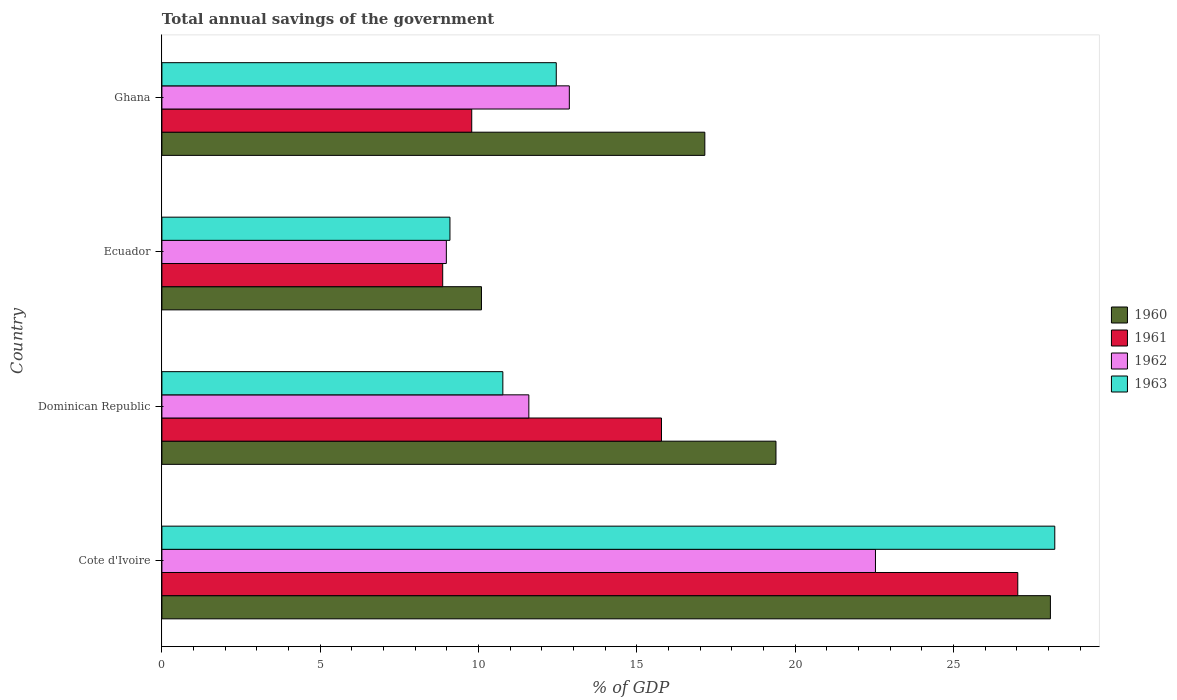How many different coloured bars are there?
Make the answer very short. 4. How many groups of bars are there?
Give a very brief answer. 4. Are the number of bars on each tick of the Y-axis equal?
Offer a very short reply. Yes. How many bars are there on the 2nd tick from the top?
Offer a terse response. 4. How many bars are there on the 4th tick from the bottom?
Offer a very short reply. 4. What is the label of the 2nd group of bars from the top?
Offer a very short reply. Ecuador. In how many cases, is the number of bars for a given country not equal to the number of legend labels?
Offer a very short reply. 0. What is the total annual savings of the government in 1960 in Dominican Republic?
Provide a short and direct response. 19.39. Across all countries, what is the maximum total annual savings of the government in 1962?
Your answer should be very brief. 22.54. Across all countries, what is the minimum total annual savings of the government in 1962?
Your answer should be compact. 8.98. In which country was the total annual savings of the government in 1963 maximum?
Provide a short and direct response. Cote d'Ivoire. In which country was the total annual savings of the government in 1963 minimum?
Give a very brief answer. Ecuador. What is the total total annual savings of the government in 1960 in the graph?
Provide a succinct answer. 74.69. What is the difference between the total annual savings of the government in 1960 in Dominican Republic and that in Ecuador?
Give a very brief answer. 9.3. What is the difference between the total annual savings of the government in 1963 in Dominican Republic and the total annual savings of the government in 1960 in Ecuador?
Your answer should be compact. 0.67. What is the average total annual savings of the government in 1963 per country?
Offer a very short reply. 15.13. What is the difference between the total annual savings of the government in 1960 and total annual savings of the government in 1961 in Dominican Republic?
Your answer should be very brief. 3.62. In how many countries, is the total annual savings of the government in 1960 greater than 19 %?
Provide a short and direct response. 2. What is the ratio of the total annual savings of the government in 1960 in Cote d'Ivoire to that in Ecuador?
Your answer should be very brief. 2.78. What is the difference between the highest and the second highest total annual savings of the government in 1963?
Give a very brief answer. 15.74. What is the difference between the highest and the lowest total annual savings of the government in 1962?
Provide a succinct answer. 13.55. What does the 4th bar from the top in Cote d'Ivoire represents?
Your response must be concise. 1960. How many bars are there?
Ensure brevity in your answer.  16. Are all the bars in the graph horizontal?
Ensure brevity in your answer.  Yes. Does the graph contain any zero values?
Your response must be concise. No. Where does the legend appear in the graph?
Offer a very short reply. Center right. How are the legend labels stacked?
Keep it short and to the point. Vertical. What is the title of the graph?
Provide a succinct answer. Total annual savings of the government. What is the label or title of the X-axis?
Offer a terse response. % of GDP. What is the % of GDP in 1960 in Cote d'Ivoire?
Provide a short and direct response. 28.06. What is the % of GDP in 1961 in Cote d'Ivoire?
Provide a short and direct response. 27.03. What is the % of GDP of 1962 in Cote d'Ivoire?
Make the answer very short. 22.54. What is the % of GDP in 1963 in Cote d'Ivoire?
Your answer should be compact. 28.2. What is the % of GDP of 1960 in Dominican Republic?
Your answer should be compact. 19.39. What is the % of GDP of 1961 in Dominican Republic?
Offer a terse response. 15.78. What is the % of GDP in 1962 in Dominican Republic?
Offer a terse response. 11.59. What is the % of GDP in 1963 in Dominican Republic?
Ensure brevity in your answer.  10.77. What is the % of GDP in 1960 in Ecuador?
Provide a short and direct response. 10.09. What is the % of GDP in 1961 in Ecuador?
Offer a terse response. 8.87. What is the % of GDP in 1962 in Ecuador?
Give a very brief answer. 8.98. What is the % of GDP in 1963 in Ecuador?
Make the answer very short. 9.1. What is the % of GDP in 1960 in Ghana?
Keep it short and to the point. 17.15. What is the % of GDP in 1961 in Ghana?
Your response must be concise. 9.78. What is the % of GDP of 1962 in Ghana?
Your answer should be compact. 12.87. What is the % of GDP in 1963 in Ghana?
Provide a succinct answer. 12.45. Across all countries, what is the maximum % of GDP of 1960?
Ensure brevity in your answer.  28.06. Across all countries, what is the maximum % of GDP in 1961?
Your answer should be compact. 27.03. Across all countries, what is the maximum % of GDP in 1962?
Your answer should be very brief. 22.54. Across all countries, what is the maximum % of GDP in 1963?
Ensure brevity in your answer.  28.2. Across all countries, what is the minimum % of GDP of 1960?
Make the answer very short. 10.09. Across all countries, what is the minimum % of GDP in 1961?
Your response must be concise. 8.87. Across all countries, what is the minimum % of GDP in 1962?
Provide a succinct answer. 8.98. Across all countries, what is the minimum % of GDP in 1963?
Provide a short and direct response. 9.1. What is the total % of GDP of 1960 in the graph?
Keep it short and to the point. 74.69. What is the total % of GDP of 1961 in the graph?
Provide a succinct answer. 61.46. What is the total % of GDP in 1962 in the graph?
Ensure brevity in your answer.  55.97. What is the total % of GDP of 1963 in the graph?
Make the answer very short. 60.52. What is the difference between the % of GDP of 1960 in Cote d'Ivoire and that in Dominican Republic?
Offer a very short reply. 8.67. What is the difference between the % of GDP of 1961 in Cote d'Ivoire and that in Dominican Republic?
Your answer should be very brief. 11.25. What is the difference between the % of GDP in 1962 in Cote d'Ivoire and that in Dominican Republic?
Your response must be concise. 10.95. What is the difference between the % of GDP in 1963 in Cote d'Ivoire and that in Dominican Republic?
Your answer should be very brief. 17.43. What is the difference between the % of GDP in 1960 in Cote d'Ivoire and that in Ecuador?
Your response must be concise. 17.97. What is the difference between the % of GDP of 1961 in Cote d'Ivoire and that in Ecuador?
Ensure brevity in your answer.  18.16. What is the difference between the % of GDP in 1962 in Cote d'Ivoire and that in Ecuador?
Offer a terse response. 13.55. What is the difference between the % of GDP in 1963 in Cote d'Ivoire and that in Ecuador?
Offer a terse response. 19.1. What is the difference between the % of GDP in 1960 in Cote d'Ivoire and that in Ghana?
Your response must be concise. 10.91. What is the difference between the % of GDP in 1961 in Cote d'Ivoire and that in Ghana?
Give a very brief answer. 17.25. What is the difference between the % of GDP in 1962 in Cote d'Ivoire and that in Ghana?
Your answer should be compact. 9.67. What is the difference between the % of GDP of 1963 in Cote d'Ivoire and that in Ghana?
Offer a terse response. 15.74. What is the difference between the % of GDP in 1960 in Dominican Republic and that in Ecuador?
Make the answer very short. 9.3. What is the difference between the % of GDP of 1961 in Dominican Republic and that in Ecuador?
Your answer should be compact. 6.91. What is the difference between the % of GDP of 1962 in Dominican Republic and that in Ecuador?
Your answer should be very brief. 2.61. What is the difference between the % of GDP of 1963 in Dominican Republic and that in Ecuador?
Keep it short and to the point. 1.67. What is the difference between the % of GDP of 1960 in Dominican Republic and that in Ghana?
Offer a terse response. 2.25. What is the difference between the % of GDP of 1961 in Dominican Republic and that in Ghana?
Make the answer very short. 5.99. What is the difference between the % of GDP of 1962 in Dominican Republic and that in Ghana?
Give a very brief answer. -1.28. What is the difference between the % of GDP in 1963 in Dominican Republic and that in Ghana?
Offer a terse response. -1.69. What is the difference between the % of GDP of 1960 in Ecuador and that in Ghana?
Your answer should be compact. -7.05. What is the difference between the % of GDP of 1961 in Ecuador and that in Ghana?
Your answer should be very brief. -0.92. What is the difference between the % of GDP of 1962 in Ecuador and that in Ghana?
Provide a succinct answer. -3.88. What is the difference between the % of GDP in 1963 in Ecuador and that in Ghana?
Ensure brevity in your answer.  -3.36. What is the difference between the % of GDP in 1960 in Cote d'Ivoire and the % of GDP in 1961 in Dominican Republic?
Provide a short and direct response. 12.28. What is the difference between the % of GDP of 1960 in Cote d'Ivoire and the % of GDP of 1962 in Dominican Republic?
Provide a short and direct response. 16.47. What is the difference between the % of GDP in 1960 in Cote d'Ivoire and the % of GDP in 1963 in Dominican Republic?
Your answer should be very brief. 17.29. What is the difference between the % of GDP of 1961 in Cote d'Ivoire and the % of GDP of 1962 in Dominican Republic?
Your answer should be very brief. 15.44. What is the difference between the % of GDP in 1961 in Cote d'Ivoire and the % of GDP in 1963 in Dominican Republic?
Your answer should be very brief. 16.26. What is the difference between the % of GDP in 1962 in Cote d'Ivoire and the % of GDP in 1963 in Dominican Republic?
Provide a short and direct response. 11.77. What is the difference between the % of GDP of 1960 in Cote d'Ivoire and the % of GDP of 1961 in Ecuador?
Your answer should be compact. 19.19. What is the difference between the % of GDP of 1960 in Cote d'Ivoire and the % of GDP of 1962 in Ecuador?
Offer a very short reply. 19.08. What is the difference between the % of GDP of 1960 in Cote d'Ivoire and the % of GDP of 1963 in Ecuador?
Your answer should be very brief. 18.96. What is the difference between the % of GDP of 1961 in Cote d'Ivoire and the % of GDP of 1962 in Ecuador?
Ensure brevity in your answer.  18.05. What is the difference between the % of GDP of 1961 in Cote d'Ivoire and the % of GDP of 1963 in Ecuador?
Make the answer very short. 17.93. What is the difference between the % of GDP in 1962 in Cote d'Ivoire and the % of GDP in 1963 in Ecuador?
Your response must be concise. 13.44. What is the difference between the % of GDP of 1960 in Cote d'Ivoire and the % of GDP of 1961 in Ghana?
Ensure brevity in your answer.  18.27. What is the difference between the % of GDP of 1960 in Cote d'Ivoire and the % of GDP of 1962 in Ghana?
Offer a terse response. 15.19. What is the difference between the % of GDP in 1960 in Cote d'Ivoire and the % of GDP in 1963 in Ghana?
Your response must be concise. 15.61. What is the difference between the % of GDP in 1961 in Cote d'Ivoire and the % of GDP in 1962 in Ghana?
Offer a very short reply. 14.16. What is the difference between the % of GDP in 1961 in Cote d'Ivoire and the % of GDP in 1963 in Ghana?
Ensure brevity in your answer.  14.58. What is the difference between the % of GDP in 1962 in Cote d'Ivoire and the % of GDP in 1963 in Ghana?
Provide a succinct answer. 10.08. What is the difference between the % of GDP of 1960 in Dominican Republic and the % of GDP of 1961 in Ecuador?
Your answer should be very brief. 10.53. What is the difference between the % of GDP of 1960 in Dominican Republic and the % of GDP of 1962 in Ecuador?
Provide a succinct answer. 10.41. What is the difference between the % of GDP in 1960 in Dominican Republic and the % of GDP in 1963 in Ecuador?
Your answer should be very brief. 10.3. What is the difference between the % of GDP of 1961 in Dominican Republic and the % of GDP of 1962 in Ecuador?
Provide a short and direct response. 6.79. What is the difference between the % of GDP of 1961 in Dominican Republic and the % of GDP of 1963 in Ecuador?
Give a very brief answer. 6.68. What is the difference between the % of GDP in 1962 in Dominican Republic and the % of GDP in 1963 in Ecuador?
Offer a very short reply. 2.49. What is the difference between the % of GDP in 1960 in Dominican Republic and the % of GDP in 1961 in Ghana?
Keep it short and to the point. 9.61. What is the difference between the % of GDP of 1960 in Dominican Republic and the % of GDP of 1962 in Ghana?
Your answer should be compact. 6.53. What is the difference between the % of GDP in 1960 in Dominican Republic and the % of GDP in 1963 in Ghana?
Give a very brief answer. 6.94. What is the difference between the % of GDP of 1961 in Dominican Republic and the % of GDP of 1962 in Ghana?
Offer a terse response. 2.91. What is the difference between the % of GDP of 1961 in Dominican Republic and the % of GDP of 1963 in Ghana?
Offer a terse response. 3.32. What is the difference between the % of GDP in 1962 in Dominican Republic and the % of GDP in 1963 in Ghana?
Your answer should be very brief. -0.87. What is the difference between the % of GDP in 1960 in Ecuador and the % of GDP in 1961 in Ghana?
Your answer should be very brief. 0.31. What is the difference between the % of GDP in 1960 in Ecuador and the % of GDP in 1962 in Ghana?
Your response must be concise. -2.77. What is the difference between the % of GDP of 1960 in Ecuador and the % of GDP of 1963 in Ghana?
Provide a succinct answer. -2.36. What is the difference between the % of GDP of 1961 in Ecuador and the % of GDP of 1962 in Ghana?
Provide a short and direct response. -4. What is the difference between the % of GDP of 1961 in Ecuador and the % of GDP of 1963 in Ghana?
Provide a short and direct response. -3.59. What is the difference between the % of GDP of 1962 in Ecuador and the % of GDP of 1963 in Ghana?
Provide a short and direct response. -3.47. What is the average % of GDP of 1960 per country?
Ensure brevity in your answer.  18.67. What is the average % of GDP of 1961 per country?
Ensure brevity in your answer.  15.37. What is the average % of GDP of 1962 per country?
Provide a succinct answer. 13.99. What is the average % of GDP of 1963 per country?
Provide a short and direct response. 15.13. What is the difference between the % of GDP of 1960 and % of GDP of 1961 in Cote d'Ivoire?
Your response must be concise. 1.03. What is the difference between the % of GDP of 1960 and % of GDP of 1962 in Cote d'Ivoire?
Your answer should be very brief. 5.52. What is the difference between the % of GDP of 1960 and % of GDP of 1963 in Cote d'Ivoire?
Your answer should be compact. -0.14. What is the difference between the % of GDP of 1961 and % of GDP of 1962 in Cote d'Ivoire?
Ensure brevity in your answer.  4.49. What is the difference between the % of GDP of 1961 and % of GDP of 1963 in Cote d'Ivoire?
Your response must be concise. -1.17. What is the difference between the % of GDP of 1962 and % of GDP of 1963 in Cote d'Ivoire?
Offer a terse response. -5.66. What is the difference between the % of GDP of 1960 and % of GDP of 1961 in Dominican Republic?
Your response must be concise. 3.62. What is the difference between the % of GDP in 1960 and % of GDP in 1962 in Dominican Republic?
Ensure brevity in your answer.  7.8. What is the difference between the % of GDP in 1960 and % of GDP in 1963 in Dominican Republic?
Provide a succinct answer. 8.63. What is the difference between the % of GDP of 1961 and % of GDP of 1962 in Dominican Republic?
Give a very brief answer. 4.19. What is the difference between the % of GDP of 1961 and % of GDP of 1963 in Dominican Republic?
Your response must be concise. 5.01. What is the difference between the % of GDP in 1962 and % of GDP in 1963 in Dominican Republic?
Provide a short and direct response. 0.82. What is the difference between the % of GDP of 1960 and % of GDP of 1961 in Ecuador?
Your answer should be compact. 1.22. What is the difference between the % of GDP of 1960 and % of GDP of 1962 in Ecuador?
Provide a succinct answer. 1.11. What is the difference between the % of GDP in 1961 and % of GDP in 1962 in Ecuador?
Give a very brief answer. -0.12. What is the difference between the % of GDP in 1961 and % of GDP in 1963 in Ecuador?
Ensure brevity in your answer.  -0.23. What is the difference between the % of GDP of 1962 and % of GDP of 1963 in Ecuador?
Provide a succinct answer. -0.11. What is the difference between the % of GDP in 1960 and % of GDP in 1961 in Ghana?
Your response must be concise. 7.36. What is the difference between the % of GDP in 1960 and % of GDP in 1962 in Ghana?
Your response must be concise. 4.28. What is the difference between the % of GDP in 1960 and % of GDP in 1963 in Ghana?
Make the answer very short. 4.69. What is the difference between the % of GDP in 1961 and % of GDP in 1962 in Ghana?
Provide a short and direct response. -3.08. What is the difference between the % of GDP in 1961 and % of GDP in 1963 in Ghana?
Keep it short and to the point. -2.67. What is the difference between the % of GDP of 1962 and % of GDP of 1963 in Ghana?
Give a very brief answer. 0.41. What is the ratio of the % of GDP of 1960 in Cote d'Ivoire to that in Dominican Republic?
Keep it short and to the point. 1.45. What is the ratio of the % of GDP of 1961 in Cote d'Ivoire to that in Dominican Republic?
Provide a short and direct response. 1.71. What is the ratio of the % of GDP in 1962 in Cote d'Ivoire to that in Dominican Republic?
Make the answer very short. 1.94. What is the ratio of the % of GDP of 1963 in Cote d'Ivoire to that in Dominican Republic?
Give a very brief answer. 2.62. What is the ratio of the % of GDP in 1960 in Cote d'Ivoire to that in Ecuador?
Provide a succinct answer. 2.78. What is the ratio of the % of GDP in 1961 in Cote d'Ivoire to that in Ecuador?
Your answer should be compact. 3.05. What is the ratio of the % of GDP in 1962 in Cote d'Ivoire to that in Ecuador?
Your answer should be compact. 2.51. What is the ratio of the % of GDP of 1963 in Cote d'Ivoire to that in Ecuador?
Offer a very short reply. 3.1. What is the ratio of the % of GDP of 1960 in Cote d'Ivoire to that in Ghana?
Provide a succinct answer. 1.64. What is the ratio of the % of GDP of 1961 in Cote d'Ivoire to that in Ghana?
Offer a very short reply. 2.76. What is the ratio of the % of GDP in 1962 in Cote d'Ivoire to that in Ghana?
Your response must be concise. 1.75. What is the ratio of the % of GDP of 1963 in Cote d'Ivoire to that in Ghana?
Give a very brief answer. 2.26. What is the ratio of the % of GDP in 1960 in Dominican Republic to that in Ecuador?
Provide a succinct answer. 1.92. What is the ratio of the % of GDP of 1961 in Dominican Republic to that in Ecuador?
Provide a short and direct response. 1.78. What is the ratio of the % of GDP of 1962 in Dominican Republic to that in Ecuador?
Your answer should be very brief. 1.29. What is the ratio of the % of GDP of 1963 in Dominican Republic to that in Ecuador?
Offer a terse response. 1.18. What is the ratio of the % of GDP in 1960 in Dominican Republic to that in Ghana?
Offer a very short reply. 1.13. What is the ratio of the % of GDP of 1961 in Dominican Republic to that in Ghana?
Give a very brief answer. 1.61. What is the ratio of the % of GDP in 1962 in Dominican Republic to that in Ghana?
Make the answer very short. 0.9. What is the ratio of the % of GDP in 1963 in Dominican Republic to that in Ghana?
Keep it short and to the point. 0.86. What is the ratio of the % of GDP of 1960 in Ecuador to that in Ghana?
Your answer should be compact. 0.59. What is the ratio of the % of GDP in 1961 in Ecuador to that in Ghana?
Your answer should be very brief. 0.91. What is the ratio of the % of GDP in 1962 in Ecuador to that in Ghana?
Your answer should be compact. 0.7. What is the ratio of the % of GDP of 1963 in Ecuador to that in Ghana?
Keep it short and to the point. 0.73. What is the difference between the highest and the second highest % of GDP of 1960?
Make the answer very short. 8.67. What is the difference between the highest and the second highest % of GDP in 1961?
Your response must be concise. 11.25. What is the difference between the highest and the second highest % of GDP of 1962?
Give a very brief answer. 9.67. What is the difference between the highest and the second highest % of GDP of 1963?
Keep it short and to the point. 15.74. What is the difference between the highest and the lowest % of GDP of 1960?
Give a very brief answer. 17.97. What is the difference between the highest and the lowest % of GDP in 1961?
Your answer should be compact. 18.16. What is the difference between the highest and the lowest % of GDP in 1962?
Provide a succinct answer. 13.55. What is the difference between the highest and the lowest % of GDP of 1963?
Your response must be concise. 19.1. 